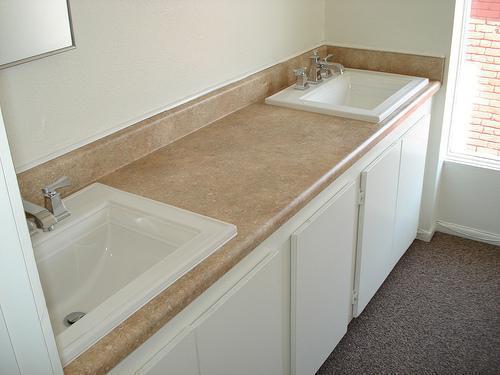How many sinks are there?
Give a very brief answer. 2. 